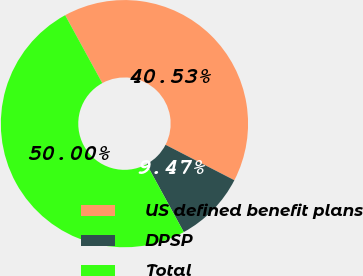<chart> <loc_0><loc_0><loc_500><loc_500><pie_chart><fcel>US defined benefit plans<fcel>DPSP<fcel>Total<nl><fcel>40.53%<fcel>9.47%<fcel>50.0%<nl></chart> 